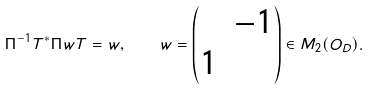Convert formula to latex. <formula><loc_0><loc_0><loc_500><loc_500>\Pi ^ { - 1 } T ^ { * } \Pi w T = w , \quad w = \begin{pmatrix} & - 1 \\ 1 & \end{pmatrix} \in M _ { 2 } ( O _ { D } ) .</formula> 